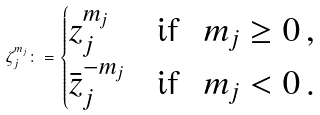<formula> <loc_0><loc_0><loc_500><loc_500>\zeta _ { j } ^ { m _ { j } } \colon = \begin{cases} z _ { j } ^ { m _ { j } } & \text {if } \ m _ { j } \geq 0 \, , \\ \bar { z } _ { j } ^ { - m _ { j } } & \text {if } \ m _ { j } < 0 \, . \end{cases}</formula> 